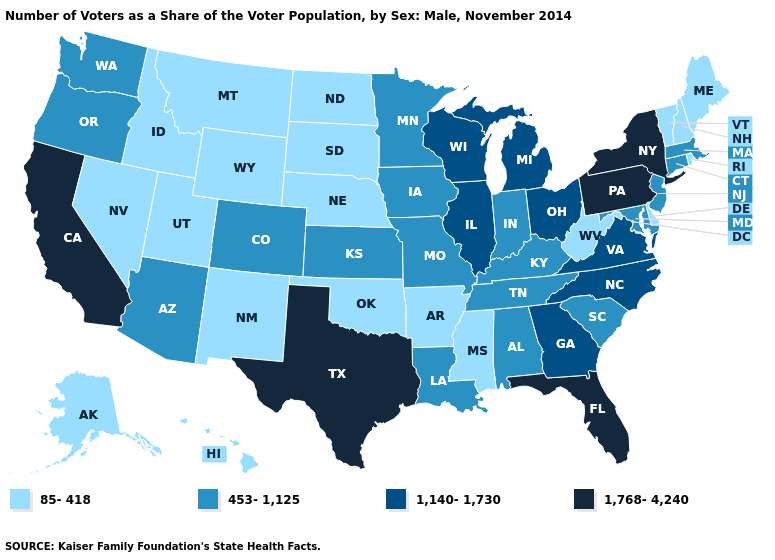What is the lowest value in states that border Connecticut?
Answer briefly. 85-418. What is the lowest value in the West?
Quick response, please. 85-418. What is the lowest value in the USA?
Concise answer only. 85-418. Does New York have the highest value in the Northeast?
Keep it brief. Yes. What is the highest value in the USA?
Concise answer only. 1,768-4,240. Which states have the highest value in the USA?
Keep it brief. California, Florida, New York, Pennsylvania, Texas. Which states have the highest value in the USA?
Concise answer only. California, Florida, New York, Pennsylvania, Texas. What is the highest value in the USA?
Short answer required. 1,768-4,240. What is the value of Iowa?
Give a very brief answer. 453-1,125. What is the value of New Mexico?
Concise answer only. 85-418. Does the first symbol in the legend represent the smallest category?
Concise answer only. Yes. What is the lowest value in the USA?
Short answer required. 85-418. How many symbols are there in the legend?
Answer briefly. 4. Name the states that have a value in the range 1,140-1,730?
Concise answer only. Georgia, Illinois, Michigan, North Carolina, Ohio, Virginia, Wisconsin. Does Hawaii have a lower value than Maine?
Keep it brief. No. 